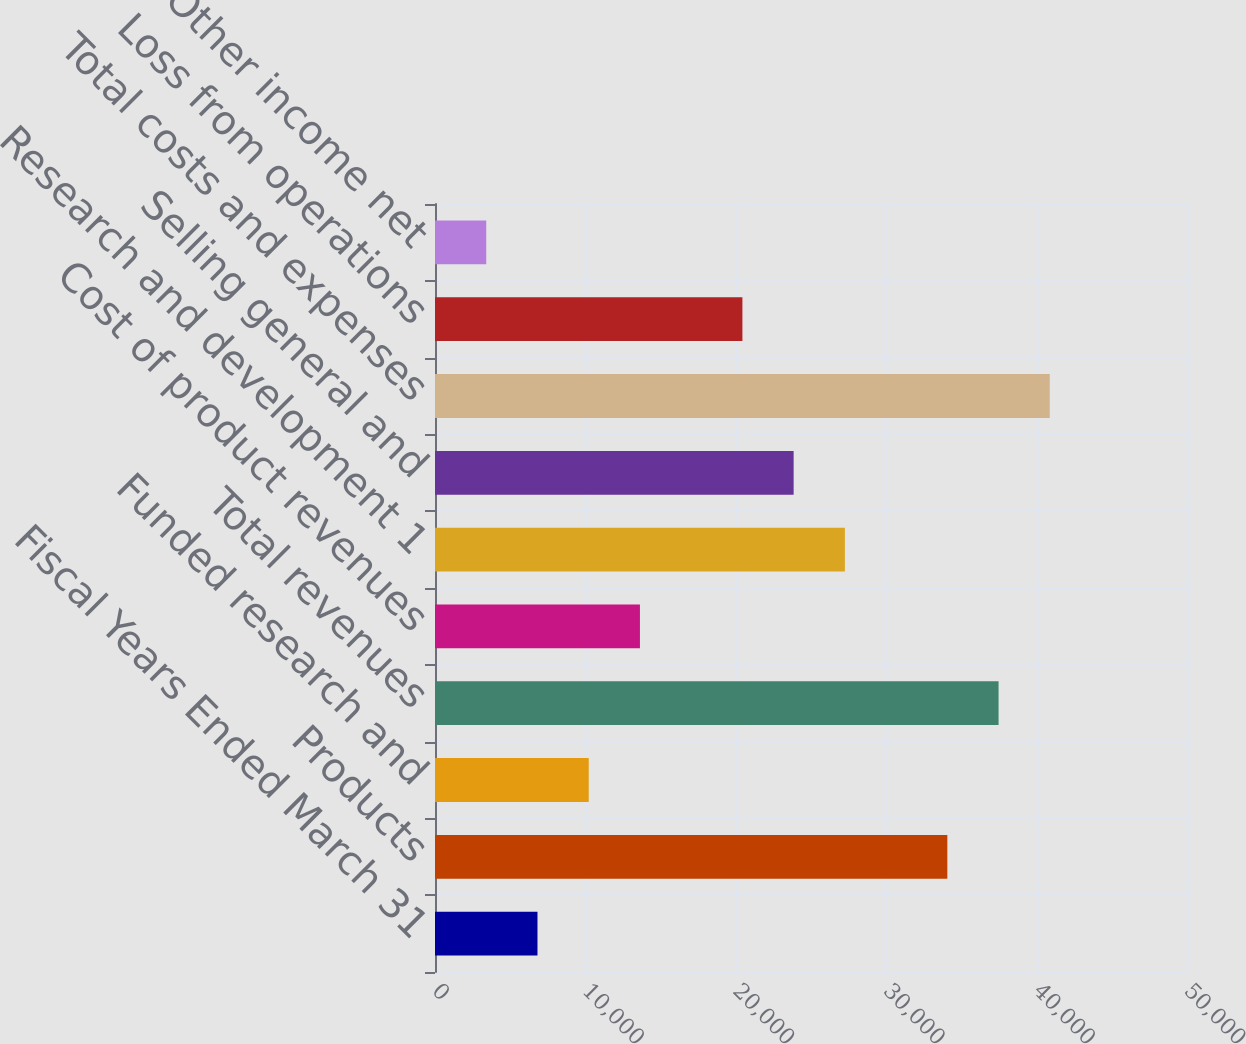Convert chart to OTSL. <chart><loc_0><loc_0><loc_500><loc_500><bar_chart><fcel>Fiscal Years Ended March 31<fcel>Products<fcel>Funded research and<fcel>Total revenues<fcel>Cost of product revenues<fcel>Research and development 1<fcel>Selling general and<fcel>Total costs and expenses<fcel>Loss from operations<fcel>Other income net<nl><fcel>6813.44<fcel>34065<fcel>10219.9<fcel>37471.4<fcel>13626.3<fcel>27252.1<fcel>23845.6<fcel>40877.8<fcel>20439.2<fcel>3407<nl></chart> 